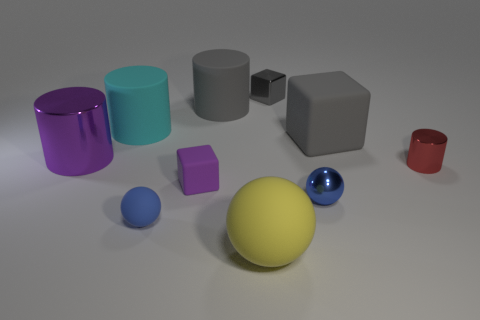Subtract all gray matte cubes. How many cubes are left? 2 Subtract all cyan cylinders. How many cylinders are left? 3 Subtract 1 blocks. How many blocks are left? 2 Subtract all green cylinders. Subtract all brown balls. How many cylinders are left? 4 Subtract all tiny brown metal spheres. Subtract all blue shiny objects. How many objects are left? 9 Add 9 tiny shiny blocks. How many tiny shiny blocks are left? 10 Add 2 tiny red metallic things. How many tiny red metallic things exist? 3 Subtract 0 red blocks. How many objects are left? 10 Subtract all blocks. How many objects are left? 7 